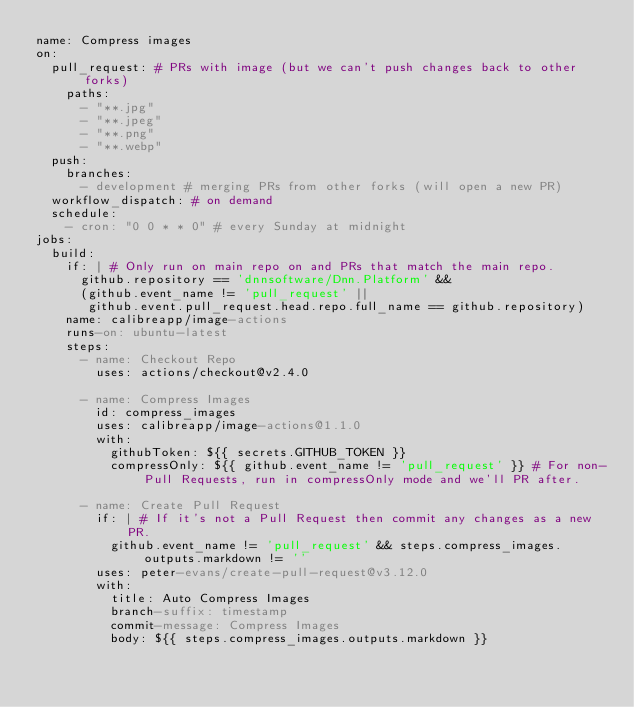<code> <loc_0><loc_0><loc_500><loc_500><_YAML_>name: Compress images
on:
  pull_request: # PRs with image (but we can't push changes back to other forks)
    paths:
      - "**.jpg"
      - "**.jpeg"
      - "**.png"
      - "**.webp"
  push:
    branches:
      - development # merging PRs from other forks (will open a new PR)
  workflow_dispatch: # on demand
  schedule:
    - cron: "0 0 * * 0" # every Sunday at midnight
jobs:
  build:
    if: | # Only run on main repo on and PRs that match the main repo.
      github.repository == 'dnnsoftware/Dnn.Platform' &&
      (github.event_name != 'pull_request' ||
       github.event.pull_request.head.repo.full_name == github.repository)
    name: calibreapp/image-actions
    runs-on: ubuntu-latest
    steps:
      - name: Checkout Repo
        uses: actions/checkout@v2.4.0

      - name: Compress Images
        id: compress_images
        uses: calibreapp/image-actions@1.1.0
        with:
          githubToken: ${{ secrets.GITHUB_TOKEN }}
          compressOnly: ${{ github.event_name != 'pull_request' }} # For non-Pull Requests, run in compressOnly mode and we'll PR after.

      - name: Create Pull Request
        if: | # If it's not a Pull Request then commit any changes as a new PR.
          github.event_name != 'pull_request' && steps.compress_images.outputs.markdown != ''
        uses: peter-evans/create-pull-request@v3.12.0
        with:
          title: Auto Compress Images
          branch-suffix: timestamp
          commit-message: Compress Images
          body: ${{ steps.compress_images.outputs.markdown }}
</code> 